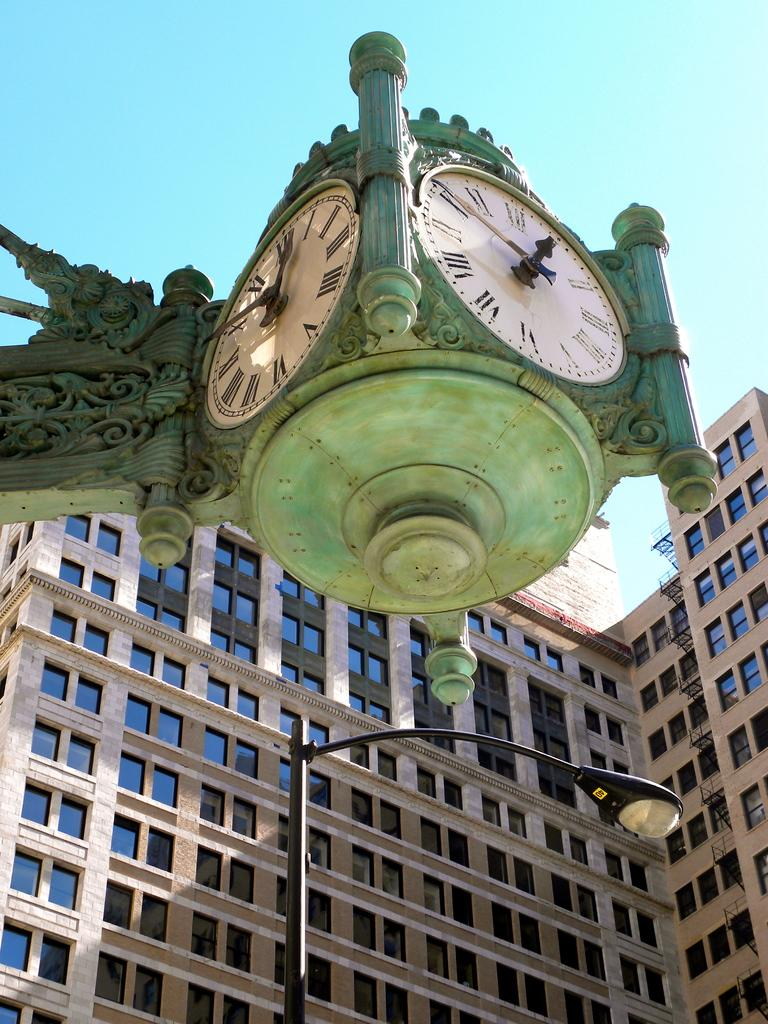<image>
Describe the image concisely. A clock says that it is 12:50 in the afternoon. 